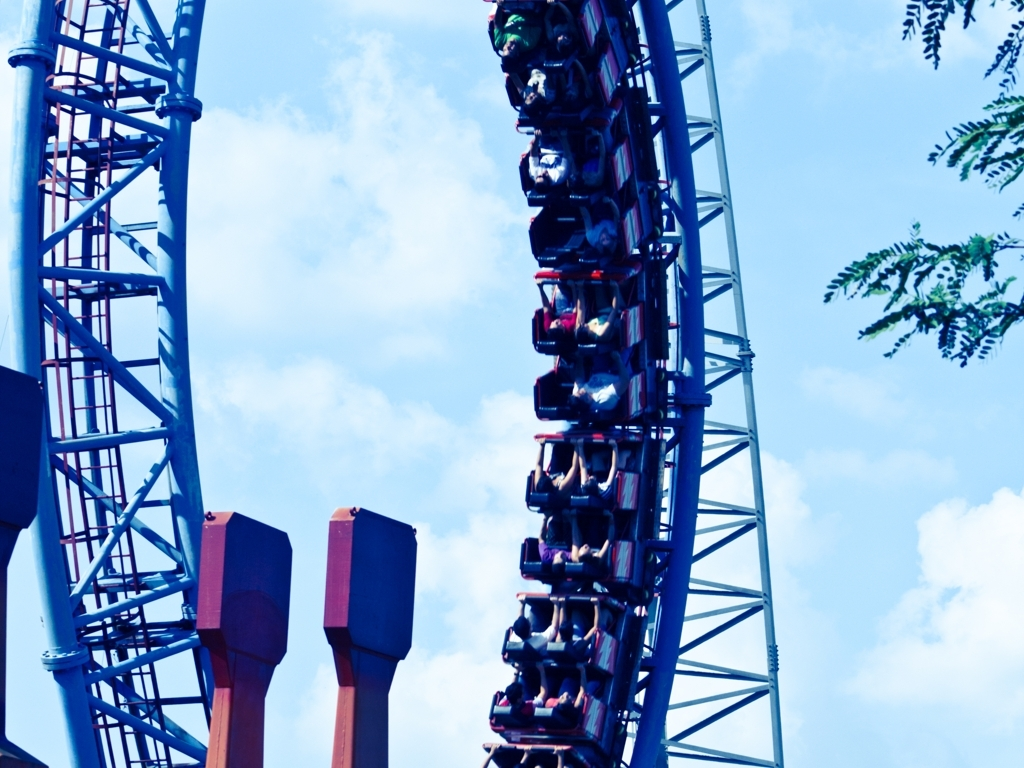Can you give me some details about the structural elements visible in the photo? Certainly! The image features a steel structure with blue-painted tracks and large supporting columns, which are maroon with noticeable rivets and gusset plates. These are designed to ensure maximum stability and safety for the riders as the coaster navigates through high-speed turns and drops. What does the color scheme of the coaster suggest? The color scheme of deep blue for the tracks and maroon for the supports gives the roller coaster a vibrant and dynamic appearance. This choice of colors may be intended to evoke excitement and a sense of adventure among the riders and spectators. 